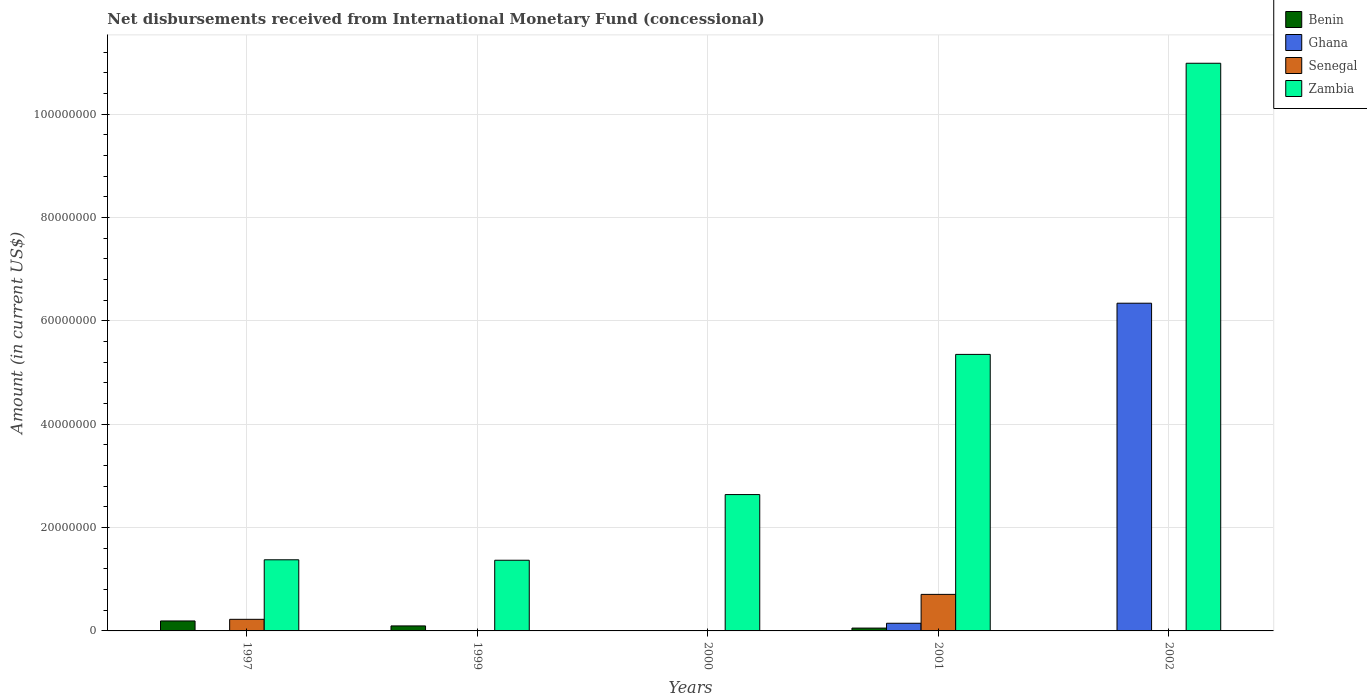How many different coloured bars are there?
Offer a very short reply. 4. How many bars are there on the 5th tick from the left?
Give a very brief answer. 2. How many bars are there on the 1st tick from the right?
Give a very brief answer. 2. What is the label of the 2nd group of bars from the left?
Your response must be concise. 1999. In how many cases, is the number of bars for a given year not equal to the number of legend labels?
Give a very brief answer. 4. What is the amount of disbursements received from International Monetary Fund in Benin in 1999?
Offer a very short reply. 9.68e+05. Across all years, what is the maximum amount of disbursements received from International Monetary Fund in Benin?
Make the answer very short. 1.93e+06. In which year was the amount of disbursements received from International Monetary Fund in Senegal maximum?
Your response must be concise. 2001. What is the total amount of disbursements received from International Monetary Fund in Senegal in the graph?
Give a very brief answer. 9.31e+06. What is the difference between the amount of disbursements received from International Monetary Fund in Zambia in 2000 and that in 2001?
Provide a succinct answer. -2.71e+07. What is the difference between the amount of disbursements received from International Monetary Fund in Ghana in 2001 and the amount of disbursements received from International Monetary Fund in Zambia in 2002?
Provide a succinct answer. -1.08e+08. What is the average amount of disbursements received from International Monetary Fund in Ghana per year?
Make the answer very short. 1.30e+07. In the year 2001, what is the difference between the amount of disbursements received from International Monetary Fund in Benin and amount of disbursements received from International Monetary Fund in Ghana?
Your response must be concise. -9.34e+05. What is the ratio of the amount of disbursements received from International Monetary Fund in Zambia in 1997 to that in 2002?
Offer a very short reply. 0.13. Is the amount of disbursements received from International Monetary Fund in Benin in 1997 less than that in 1999?
Provide a short and direct response. No. What is the difference between the highest and the second highest amount of disbursements received from International Monetary Fund in Benin?
Make the answer very short. 9.59e+05. What is the difference between the highest and the lowest amount of disbursements received from International Monetary Fund in Ghana?
Offer a terse response. 6.34e+07. Is it the case that in every year, the sum of the amount of disbursements received from International Monetary Fund in Ghana and amount of disbursements received from International Monetary Fund in Benin is greater than the sum of amount of disbursements received from International Monetary Fund in Senegal and amount of disbursements received from International Monetary Fund in Zambia?
Provide a short and direct response. No. Is it the case that in every year, the sum of the amount of disbursements received from International Monetary Fund in Benin and amount of disbursements received from International Monetary Fund in Senegal is greater than the amount of disbursements received from International Monetary Fund in Ghana?
Provide a succinct answer. No. How many bars are there?
Your response must be concise. 12. Are all the bars in the graph horizontal?
Offer a very short reply. No. How many years are there in the graph?
Your response must be concise. 5. What is the difference between two consecutive major ticks on the Y-axis?
Offer a terse response. 2.00e+07. Does the graph contain grids?
Keep it short and to the point. Yes. Where does the legend appear in the graph?
Your answer should be very brief. Top right. How many legend labels are there?
Offer a very short reply. 4. How are the legend labels stacked?
Offer a very short reply. Vertical. What is the title of the graph?
Make the answer very short. Net disbursements received from International Monetary Fund (concessional). Does "Albania" appear as one of the legend labels in the graph?
Your answer should be compact. No. What is the label or title of the X-axis?
Offer a very short reply. Years. What is the Amount (in current US$) in Benin in 1997?
Keep it short and to the point. 1.93e+06. What is the Amount (in current US$) in Senegal in 1997?
Make the answer very short. 2.24e+06. What is the Amount (in current US$) of Zambia in 1997?
Ensure brevity in your answer.  1.38e+07. What is the Amount (in current US$) of Benin in 1999?
Provide a succinct answer. 9.68e+05. What is the Amount (in current US$) in Senegal in 1999?
Keep it short and to the point. 0. What is the Amount (in current US$) of Zambia in 1999?
Ensure brevity in your answer.  1.37e+07. What is the Amount (in current US$) in Benin in 2000?
Your response must be concise. 0. What is the Amount (in current US$) in Ghana in 2000?
Your answer should be very brief. 0. What is the Amount (in current US$) in Zambia in 2000?
Ensure brevity in your answer.  2.64e+07. What is the Amount (in current US$) in Benin in 2001?
Ensure brevity in your answer.  5.49e+05. What is the Amount (in current US$) in Ghana in 2001?
Provide a short and direct response. 1.48e+06. What is the Amount (in current US$) of Senegal in 2001?
Your response must be concise. 7.07e+06. What is the Amount (in current US$) in Zambia in 2001?
Your response must be concise. 5.35e+07. What is the Amount (in current US$) in Ghana in 2002?
Your response must be concise. 6.34e+07. What is the Amount (in current US$) of Senegal in 2002?
Provide a short and direct response. 0. What is the Amount (in current US$) in Zambia in 2002?
Offer a very short reply. 1.10e+08. Across all years, what is the maximum Amount (in current US$) in Benin?
Provide a succinct answer. 1.93e+06. Across all years, what is the maximum Amount (in current US$) of Ghana?
Make the answer very short. 6.34e+07. Across all years, what is the maximum Amount (in current US$) of Senegal?
Make the answer very short. 7.07e+06. Across all years, what is the maximum Amount (in current US$) of Zambia?
Your answer should be compact. 1.10e+08. Across all years, what is the minimum Amount (in current US$) of Benin?
Your response must be concise. 0. Across all years, what is the minimum Amount (in current US$) of Zambia?
Provide a short and direct response. 1.37e+07. What is the total Amount (in current US$) in Benin in the graph?
Your response must be concise. 3.44e+06. What is the total Amount (in current US$) in Ghana in the graph?
Provide a short and direct response. 6.49e+07. What is the total Amount (in current US$) of Senegal in the graph?
Your answer should be compact. 9.31e+06. What is the total Amount (in current US$) of Zambia in the graph?
Make the answer very short. 2.17e+08. What is the difference between the Amount (in current US$) of Benin in 1997 and that in 1999?
Your answer should be very brief. 9.59e+05. What is the difference between the Amount (in current US$) in Zambia in 1997 and that in 1999?
Provide a short and direct response. 8.70e+04. What is the difference between the Amount (in current US$) of Zambia in 1997 and that in 2000?
Offer a very short reply. -1.26e+07. What is the difference between the Amount (in current US$) of Benin in 1997 and that in 2001?
Offer a terse response. 1.38e+06. What is the difference between the Amount (in current US$) in Senegal in 1997 and that in 2001?
Make the answer very short. -4.83e+06. What is the difference between the Amount (in current US$) of Zambia in 1997 and that in 2001?
Keep it short and to the point. -3.97e+07. What is the difference between the Amount (in current US$) of Zambia in 1997 and that in 2002?
Provide a short and direct response. -9.61e+07. What is the difference between the Amount (in current US$) in Zambia in 1999 and that in 2000?
Your answer should be compact. -1.27e+07. What is the difference between the Amount (in current US$) in Benin in 1999 and that in 2001?
Provide a short and direct response. 4.19e+05. What is the difference between the Amount (in current US$) in Zambia in 1999 and that in 2001?
Offer a very short reply. -3.98e+07. What is the difference between the Amount (in current US$) in Zambia in 1999 and that in 2002?
Offer a terse response. -9.61e+07. What is the difference between the Amount (in current US$) in Zambia in 2000 and that in 2001?
Provide a succinct answer. -2.71e+07. What is the difference between the Amount (in current US$) of Zambia in 2000 and that in 2002?
Provide a succinct answer. -8.34e+07. What is the difference between the Amount (in current US$) of Ghana in 2001 and that in 2002?
Your answer should be very brief. -6.19e+07. What is the difference between the Amount (in current US$) in Zambia in 2001 and that in 2002?
Keep it short and to the point. -5.63e+07. What is the difference between the Amount (in current US$) in Benin in 1997 and the Amount (in current US$) in Zambia in 1999?
Provide a succinct answer. -1.17e+07. What is the difference between the Amount (in current US$) of Senegal in 1997 and the Amount (in current US$) of Zambia in 1999?
Give a very brief answer. -1.14e+07. What is the difference between the Amount (in current US$) in Benin in 1997 and the Amount (in current US$) in Zambia in 2000?
Offer a terse response. -2.45e+07. What is the difference between the Amount (in current US$) in Senegal in 1997 and the Amount (in current US$) in Zambia in 2000?
Give a very brief answer. -2.41e+07. What is the difference between the Amount (in current US$) of Benin in 1997 and the Amount (in current US$) of Ghana in 2001?
Your response must be concise. 4.44e+05. What is the difference between the Amount (in current US$) of Benin in 1997 and the Amount (in current US$) of Senegal in 2001?
Your response must be concise. -5.14e+06. What is the difference between the Amount (in current US$) in Benin in 1997 and the Amount (in current US$) in Zambia in 2001?
Offer a terse response. -5.16e+07. What is the difference between the Amount (in current US$) in Senegal in 1997 and the Amount (in current US$) in Zambia in 2001?
Provide a short and direct response. -5.13e+07. What is the difference between the Amount (in current US$) of Benin in 1997 and the Amount (in current US$) of Ghana in 2002?
Make the answer very short. -6.15e+07. What is the difference between the Amount (in current US$) in Benin in 1997 and the Amount (in current US$) in Zambia in 2002?
Keep it short and to the point. -1.08e+08. What is the difference between the Amount (in current US$) of Senegal in 1997 and the Amount (in current US$) of Zambia in 2002?
Provide a short and direct response. -1.08e+08. What is the difference between the Amount (in current US$) of Benin in 1999 and the Amount (in current US$) of Zambia in 2000?
Your answer should be very brief. -2.54e+07. What is the difference between the Amount (in current US$) in Benin in 1999 and the Amount (in current US$) in Ghana in 2001?
Give a very brief answer. -5.15e+05. What is the difference between the Amount (in current US$) of Benin in 1999 and the Amount (in current US$) of Senegal in 2001?
Offer a terse response. -6.10e+06. What is the difference between the Amount (in current US$) of Benin in 1999 and the Amount (in current US$) of Zambia in 2001?
Your response must be concise. -5.25e+07. What is the difference between the Amount (in current US$) of Benin in 1999 and the Amount (in current US$) of Ghana in 2002?
Give a very brief answer. -6.24e+07. What is the difference between the Amount (in current US$) in Benin in 1999 and the Amount (in current US$) in Zambia in 2002?
Your answer should be compact. -1.09e+08. What is the difference between the Amount (in current US$) of Benin in 2001 and the Amount (in current US$) of Ghana in 2002?
Offer a terse response. -6.29e+07. What is the difference between the Amount (in current US$) in Benin in 2001 and the Amount (in current US$) in Zambia in 2002?
Ensure brevity in your answer.  -1.09e+08. What is the difference between the Amount (in current US$) in Ghana in 2001 and the Amount (in current US$) in Zambia in 2002?
Your answer should be very brief. -1.08e+08. What is the difference between the Amount (in current US$) in Senegal in 2001 and the Amount (in current US$) in Zambia in 2002?
Provide a short and direct response. -1.03e+08. What is the average Amount (in current US$) in Benin per year?
Give a very brief answer. 6.89e+05. What is the average Amount (in current US$) of Ghana per year?
Keep it short and to the point. 1.30e+07. What is the average Amount (in current US$) in Senegal per year?
Ensure brevity in your answer.  1.86e+06. What is the average Amount (in current US$) of Zambia per year?
Your answer should be compact. 4.34e+07. In the year 1997, what is the difference between the Amount (in current US$) of Benin and Amount (in current US$) of Senegal?
Your response must be concise. -3.16e+05. In the year 1997, what is the difference between the Amount (in current US$) in Benin and Amount (in current US$) in Zambia?
Keep it short and to the point. -1.18e+07. In the year 1997, what is the difference between the Amount (in current US$) in Senegal and Amount (in current US$) in Zambia?
Offer a very short reply. -1.15e+07. In the year 1999, what is the difference between the Amount (in current US$) of Benin and Amount (in current US$) of Zambia?
Your answer should be compact. -1.27e+07. In the year 2001, what is the difference between the Amount (in current US$) in Benin and Amount (in current US$) in Ghana?
Provide a succinct answer. -9.34e+05. In the year 2001, what is the difference between the Amount (in current US$) in Benin and Amount (in current US$) in Senegal?
Make the answer very short. -6.52e+06. In the year 2001, what is the difference between the Amount (in current US$) of Benin and Amount (in current US$) of Zambia?
Ensure brevity in your answer.  -5.29e+07. In the year 2001, what is the difference between the Amount (in current US$) in Ghana and Amount (in current US$) in Senegal?
Provide a succinct answer. -5.59e+06. In the year 2001, what is the difference between the Amount (in current US$) of Ghana and Amount (in current US$) of Zambia?
Offer a very short reply. -5.20e+07. In the year 2001, what is the difference between the Amount (in current US$) in Senegal and Amount (in current US$) in Zambia?
Offer a very short reply. -4.64e+07. In the year 2002, what is the difference between the Amount (in current US$) of Ghana and Amount (in current US$) of Zambia?
Provide a succinct answer. -4.64e+07. What is the ratio of the Amount (in current US$) of Benin in 1997 to that in 1999?
Offer a very short reply. 1.99. What is the ratio of the Amount (in current US$) in Zambia in 1997 to that in 1999?
Keep it short and to the point. 1.01. What is the ratio of the Amount (in current US$) in Zambia in 1997 to that in 2000?
Make the answer very short. 0.52. What is the ratio of the Amount (in current US$) in Benin in 1997 to that in 2001?
Your answer should be compact. 3.51. What is the ratio of the Amount (in current US$) of Senegal in 1997 to that in 2001?
Your response must be concise. 0.32. What is the ratio of the Amount (in current US$) of Zambia in 1997 to that in 2001?
Keep it short and to the point. 0.26. What is the ratio of the Amount (in current US$) of Zambia in 1997 to that in 2002?
Your answer should be compact. 0.13. What is the ratio of the Amount (in current US$) in Zambia in 1999 to that in 2000?
Provide a succinct answer. 0.52. What is the ratio of the Amount (in current US$) of Benin in 1999 to that in 2001?
Offer a very short reply. 1.76. What is the ratio of the Amount (in current US$) of Zambia in 1999 to that in 2001?
Provide a succinct answer. 0.26. What is the ratio of the Amount (in current US$) of Zambia in 1999 to that in 2002?
Your answer should be compact. 0.12. What is the ratio of the Amount (in current US$) of Zambia in 2000 to that in 2001?
Give a very brief answer. 0.49. What is the ratio of the Amount (in current US$) in Zambia in 2000 to that in 2002?
Ensure brevity in your answer.  0.24. What is the ratio of the Amount (in current US$) in Ghana in 2001 to that in 2002?
Provide a short and direct response. 0.02. What is the ratio of the Amount (in current US$) in Zambia in 2001 to that in 2002?
Offer a very short reply. 0.49. What is the difference between the highest and the second highest Amount (in current US$) of Benin?
Your response must be concise. 9.59e+05. What is the difference between the highest and the second highest Amount (in current US$) of Zambia?
Make the answer very short. 5.63e+07. What is the difference between the highest and the lowest Amount (in current US$) of Benin?
Ensure brevity in your answer.  1.93e+06. What is the difference between the highest and the lowest Amount (in current US$) of Ghana?
Provide a short and direct response. 6.34e+07. What is the difference between the highest and the lowest Amount (in current US$) of Senegal?
Offer a terse response. 7.07e+06. What is the difference between the highest and the lowest Amount (in current US$) of Zambia?
Provide a short and direct response. 9.61e+07. 